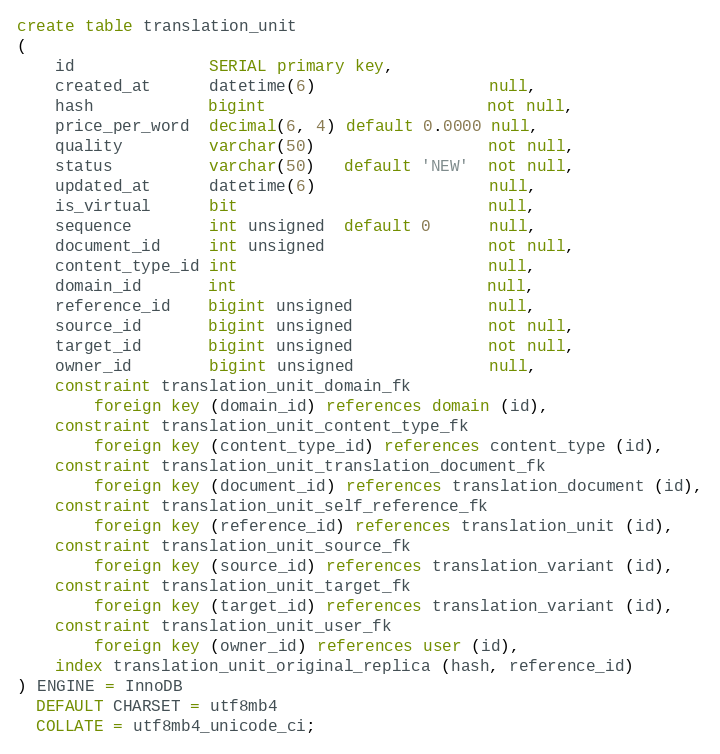Convert code to text. <code><loc_0><loc_0><loc_500><loc_500><_SQL_>create table translation_unit
(
    id              SERIAL primary key,
    created_at      datetime(6)                  null,
    hash            bigint                       not null,
    price_per_word  decimal(6, 4) default 0.0000 null,
    quality         varchar(50)                  not null,
    status          varchar(50)   default 'NEW'  not null,
    updated_at      datetime(6)                  null,
    is_virtual      bit                          null,
    sequence        int unsigned  default 0      null,
    document_id     int unsigned                 not null,
    content_type_id int                          null,
    domain_id       int                          null,
    reference_id    bigint unsigned              null,
    source_id       bigint unsigned              not null,
    target_id       bigint unsigned              not null,
    owner_id        bigint unsigned              null,
    constraint translation_unit_domain_fk
        foreign key (domain_id) references domain (id),
    constraint translation_unit_content_type_fk
        foreign key (content_type_id) references content_type (id),
    constraint translation_unit_translation_document_fk
        foreign key (document_id) references translation_document (id),
    constraint translation_unit_self_reference_fk
        foreign key (reference_id) references translation_unit (id),
    constraint translation_unit_source_fk
        foreign key (source_id) references translation_variant (id),
    constraint translation_unit_target_fk
        foreign key (target_id) references translation_variant (id),
    constraint translation_unit_user_fk
        foreign key (owner_id) references user (id),
    index translation_unit_original_replica (hash, reference_id)
) ENGINE = InnoDB
  DEFAULT CHARSET = utf8mb4
  COLLATE = utf8mb4_unicode_ci;
</code> 